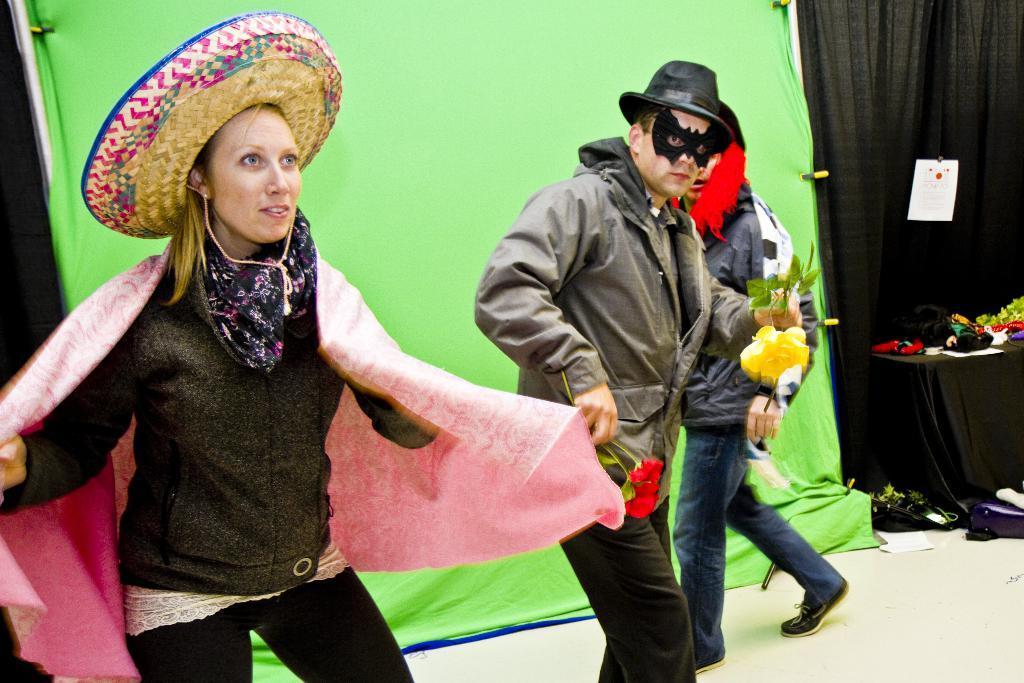In one or two sentences, can you explain what this image depicts? In this image, there are three persons standing with fancy dresses. On the right side of the image, there is a table with few objects on it. In the background, I can see a paper and the clothes. 